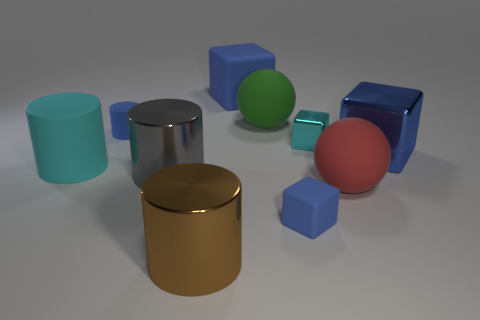Subtract all brown cylinders. How many blue cubes are left? 3 Subtract 1 cylinders. How many cylinders are left? 3 Subtract all spheres. How many objects are left? 8 Add 7 large shiny cubes. How many large shiny cubes are left? 8 Add 3 blocks. How many blocks exist? 7 Subtract 0 gray balls. How many objects are left? 10 Subtract all tiny cyan things. Subtract all tiny blue cubes. How many objects are left? 8 